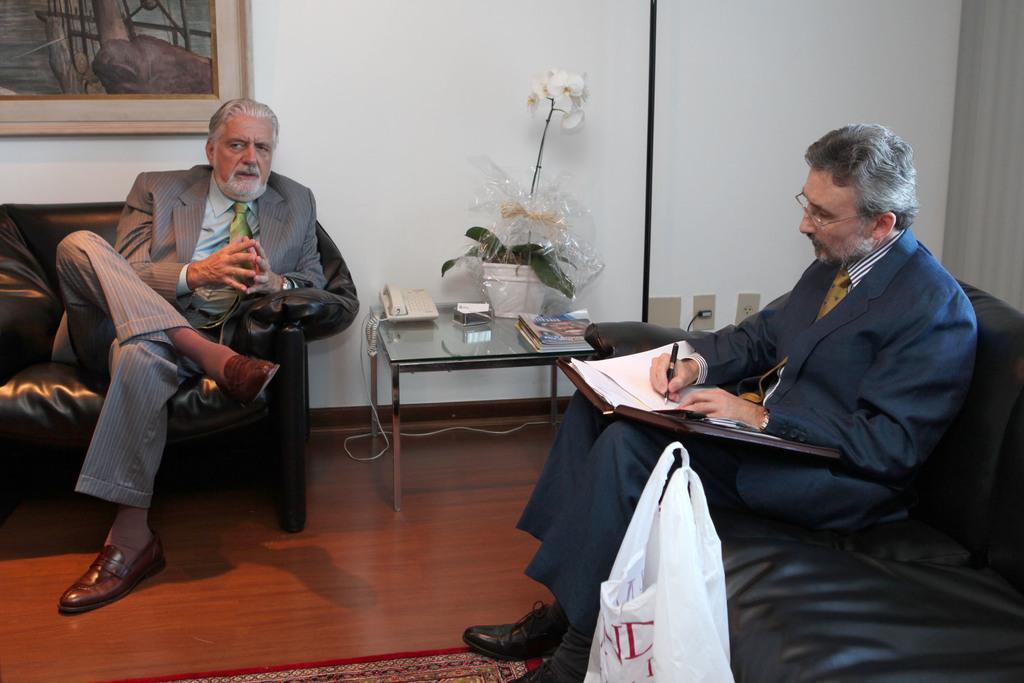How would you summarize this image in a sentence or two? in the picture there is a room in that room two persons are sitting on a sofa side by side in which one person is talking another person is writing something on the paper there is a table near the sofa on the table there are house plants there is a photo frame on the wall. 